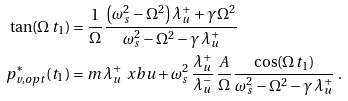Convert formula to latex. <formula><loc_0><loc_0><loc_500><loc_500>\tan ( \Omega \, t _ { 1 } ) & = \frac { 1 } { \Omega } \, \frac { \left ( \omega _ { s } ^ { 2 } - \Omega ^ { 2 } \right ) \lambda ^ { + } _ { u } + \gamma \, \Omega ^ { 2 } } { \omega _ { s } ^ { 2 } - \Omega ^ { 2 } - \gamma \, \lambda ^ { + } _ { u } } \\ p ^ { \ast } _ { v , o p t } ( t _ { 1 } ) & = m \, \lambda ^ { + } _ { u } \, \ x b u + \omega _ { s } ^ { 2 } \, \frac { \lambda ^ { + } _ { u } } { \lambda ^ { - } _ { u } } \, \frac { A } { \Omega } \, \frac { \cos ( \Omega \, t _ { 1 } ) } { \omega _ { s } ^ { 2 } - \Omega ^ { 2 } - \gamma \, \lambda ^ { + } _ { u } } \ .</formula> 